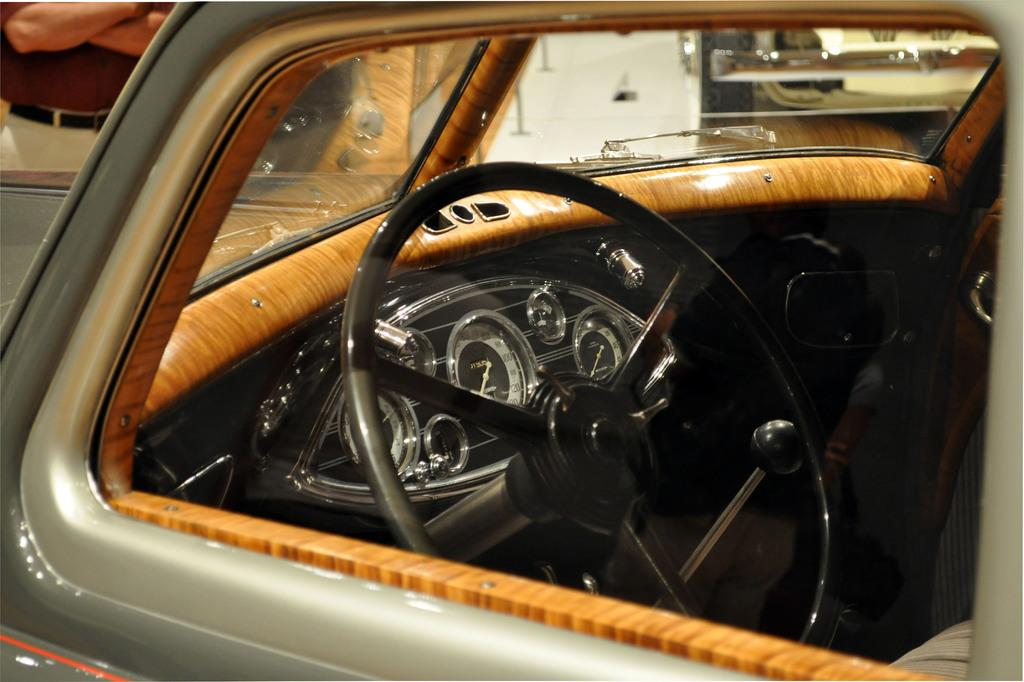What is the main subject of the picture? The main subject of the picture is a car. What can be seen in the middle of the car? There is a steering wheel in the middle of the picture. Can you describe the person in the picture? There is a person on the top left side of the picture. What type of quilt is being used to cover the car in the image? There is no quilt present in the image; it features a car with a steering wheel and a person. How many hearts can be seen on the person in the image? There are no hearts visible on the person in the image. 